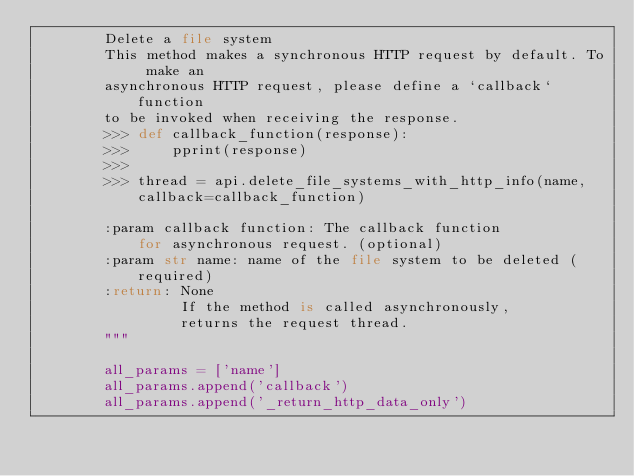<code> <loc_0><loc_0><loc_500><loc_500><_Python_>        Delete a file system
        This method makes a synchronous HTTP request by default. To make an
        asynchronous HTTP request, please define a `callback` function
        to be invoked when receiving the response.
        >>> def callback_function(response):
        >>>     pprint(response)
        >>>
        >>> thread = api.delete_file_systems_with_http_info(name, callback=callback_function)

        :param callback function: The callback function
            for asynchronous request. (optional)
        :param str name: name of the file system to be deleted (required)
        :return: None
                 If the method is called asynchronously,
                 returns the request thread.
        """

        all_params = ['name']
        all_params.append('callback')
        all_params.append('_return_http_data_only')</code> 